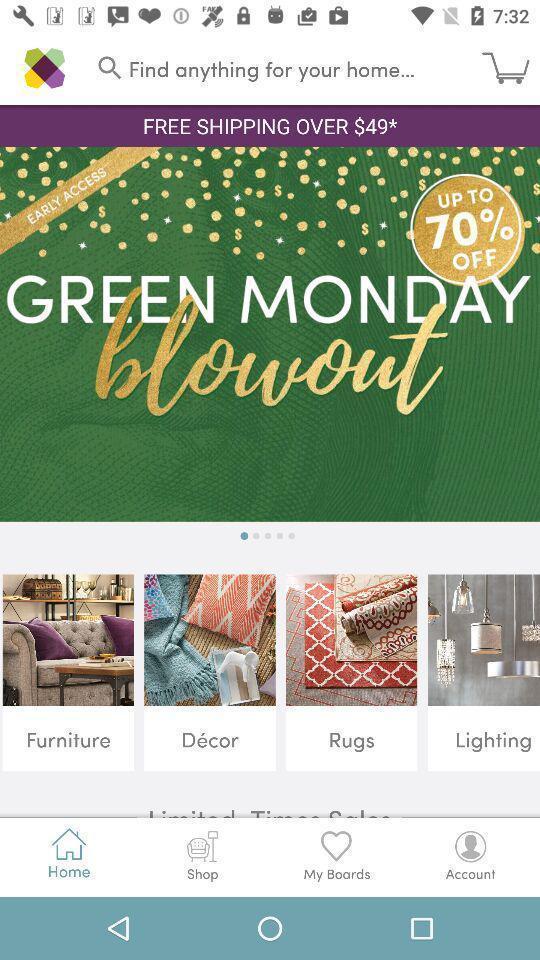Provide a detailed account of this screenshot. Screen page displaying multiple options in shopping application. 